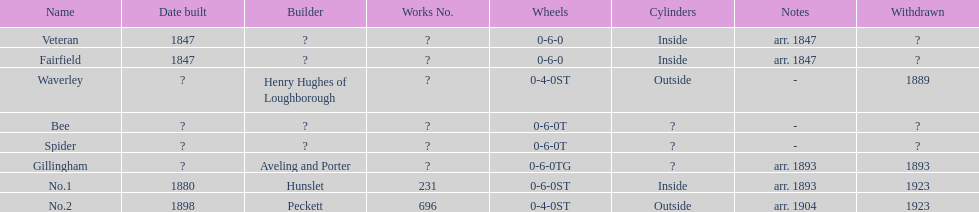Was no.1 or veteran built in 1847? Veteran. 